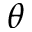<formula> <loc_0><loc_0><loc_500><loc_500>\theta</formula> 